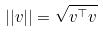Convert formula to latex. <formula><loc_0><loc_0><loc_500><loc_500>| | v | | = \sqrt { v ^ { \top } v }</formula> 